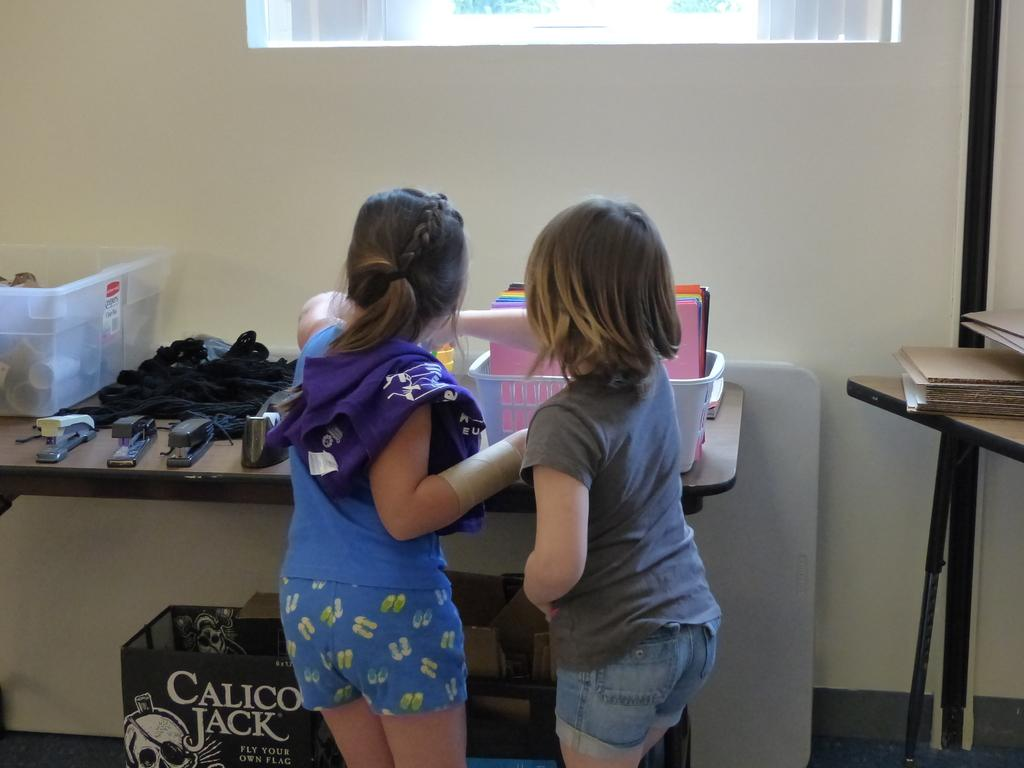Provide a one-sentence caption for the provided image. Nice to see two little girls busily sorting stationery items on a table, which is at odds with the Calico Jack box below them. 